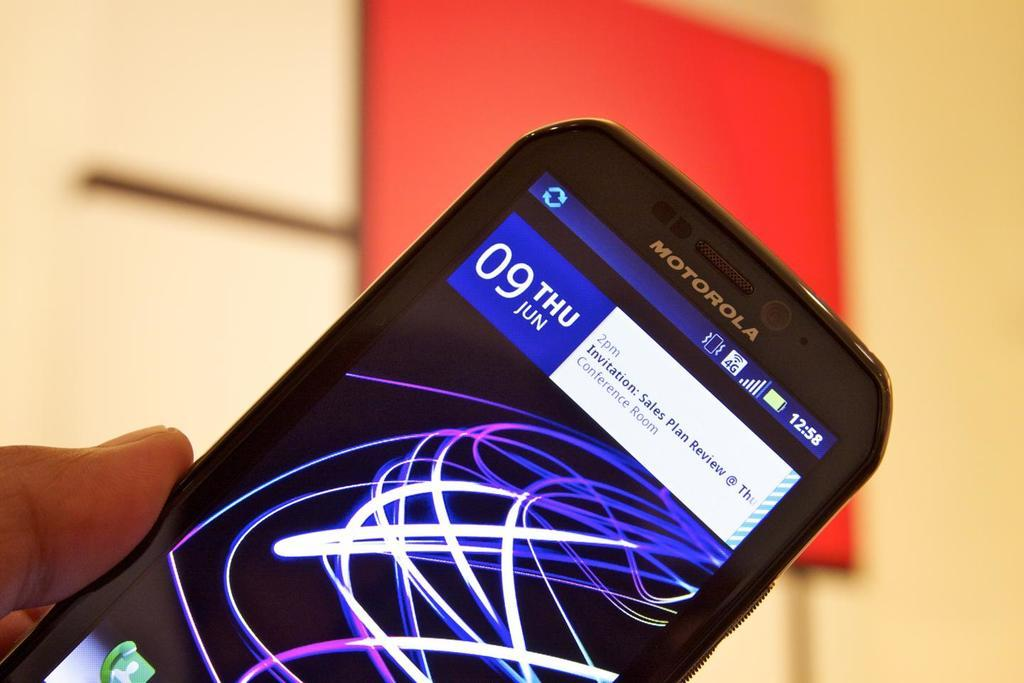Provide a one-sentence caption for the provided image. A Motorola phone is turned on to the home screen where an invitation to attend a sales plan review is displayed. 